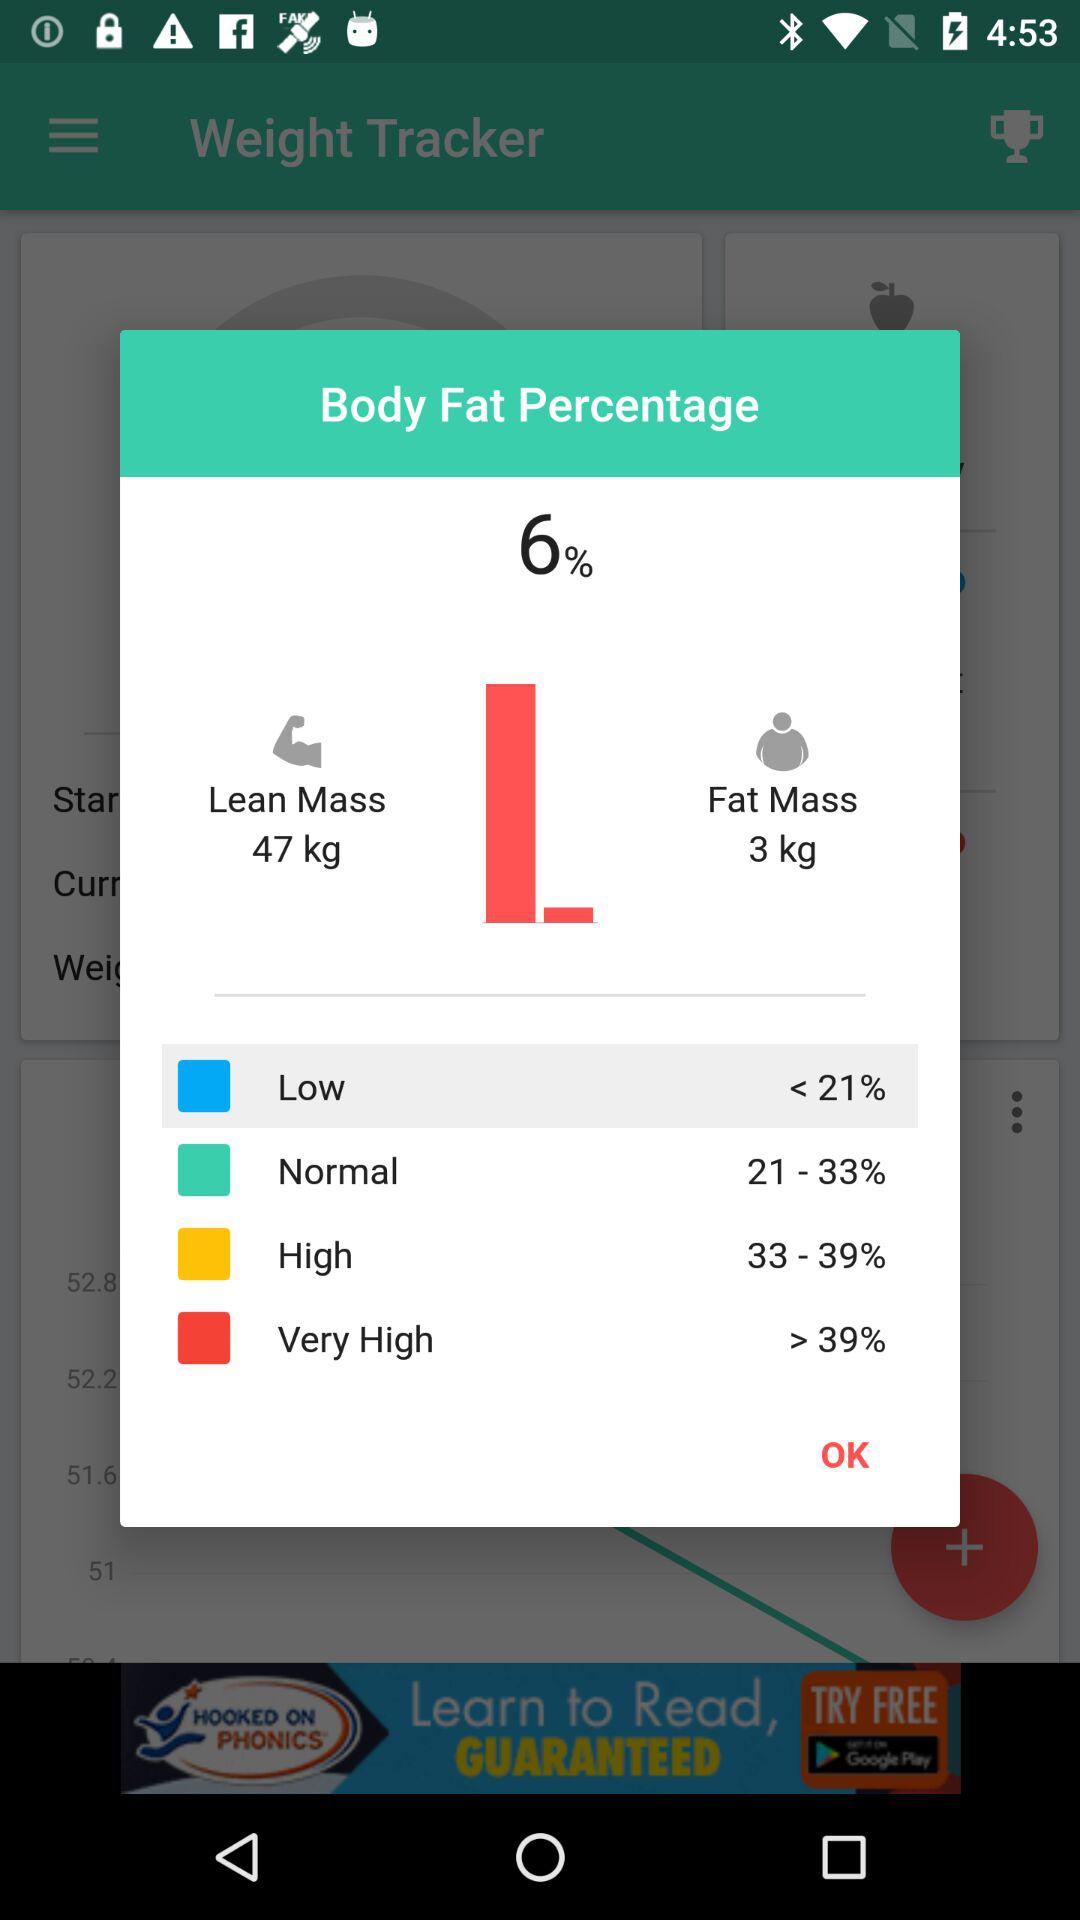What is the name of application? The name of the application is "Weight Tracker". 